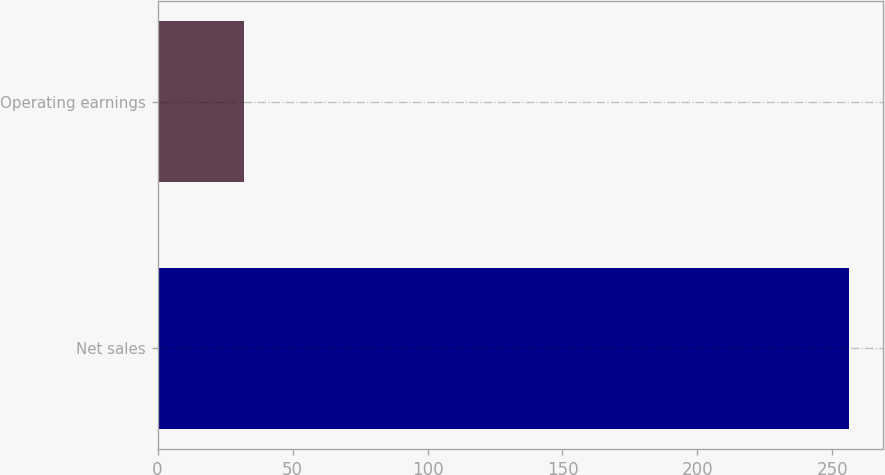<chart> <loc_0><loc_0><loc_500><loc_500><bar_chart><fcel>Net sales<fcel>Operating earnings<nl><fcel>256<fcel>32<nl></chart> 